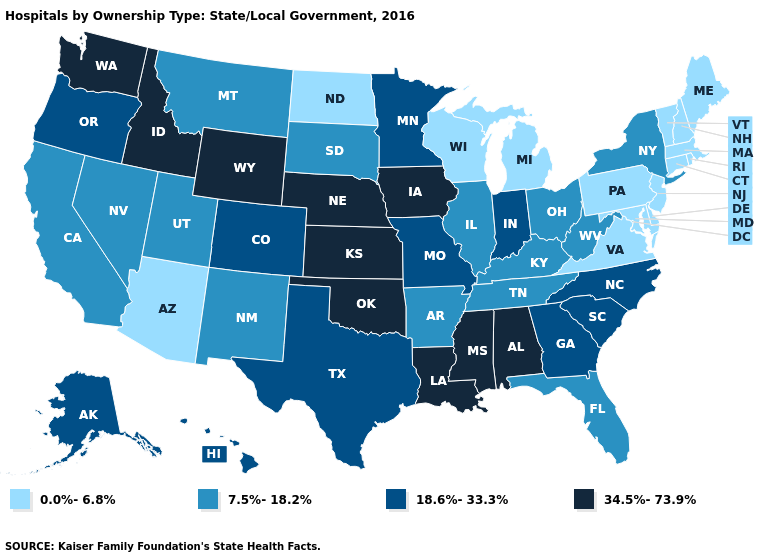What is the value of South Carolina?
Answer briefly. 18.6%-33.3%. Does the map have missing data?
Be succinct. No. What is the value of Kansas?
Quick response, please. 34.5%-73.9%. Does the first symbol in the legend represent the smallest category?
Concise answer only. Yes. Which states have the highest value in the USA?
Answer briefly. Alabama, Idaho, Iowa, Kansas, Louisiana, Mississippi, Nebraska, Oklahoma, Washington, Wyoming. Does Maine have a higher value than California?
Quick response, please. No. Among the states that border Kansas , which have the lowest value?
Short answer required. Colorado, Missouri. Does Maryland have the lowest value in the South?
Keep it brief. Yes. What is the lowest value in the USA?
Answer briefly. 0.0%-6.8%. Name the states that have a value in the range 18.6%-33.3%?
Write a very short answer. Alaska, Colorado, Georgia, Hawaii, Indiana, Minnesota, Missouri, North Carolina, Oregon, South Carolina, Texas. What is the highest value in the USA?
Quick response, please. 34.5%-73.9%. What is the lowest value in states that border Pennsylvania?
Short answer required. 0.0%-6.8%. What is the value of West Virginia?
Short answer required. 7.5%-18.2%. What is the highest value in the Northeast ?
Quick response, please. 7.5%-18.2%. Name the states that have a value in the range 7.5%-18.2%?
Quick response, please. Arkansas, California, Florida, Illinois, Kentucky, Montana, Nevada, New Mexico, New York, Ohio, South Dakota, Tennessee, Utah, West Virginia. 